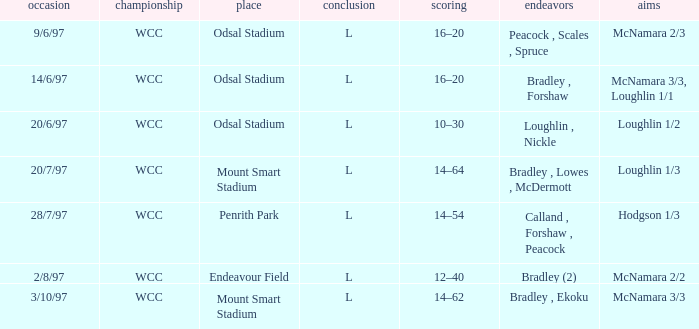What was the score on 20/6/97? 10–30. 